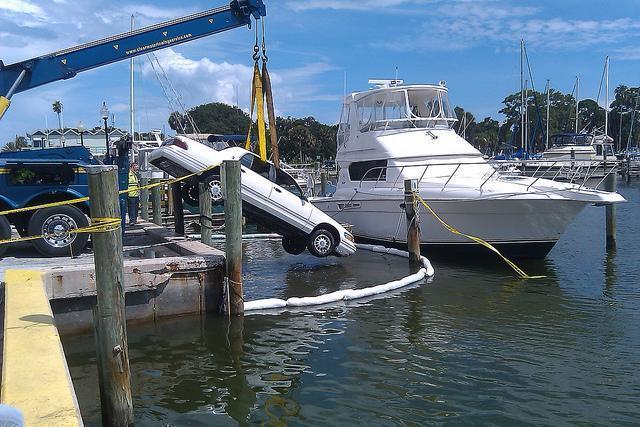How many boats are in the photo?
Give a very brief answer. 2. How many elephants are pictured?
Give a very brief answer. 0. 